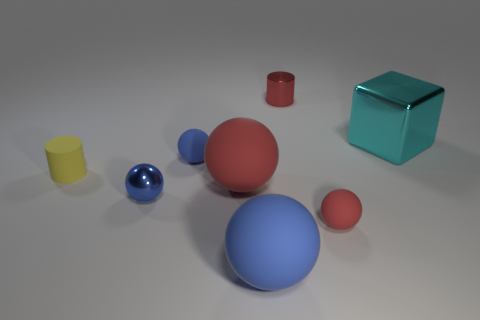Add 1 yellow objects. How many objects exist? 9 Subtract all red spheres. How many spheres are left? 3 Subtract all tiny red matte balls. How many balls are left? 4 Subtract 0 green cylinders. How many objects are left? 8 Subtract all cylinders. How many objects are left? 6 Subtract 1 blocks. How many blocks are left? 0 Subtract all purple balls. Subtract all red blocks. How many balls are left? 5 Subtract all brown cylinders. How many green balls are left? 0 Subtract all tiny blue metal balls. Subtract all blue rubber spheres. How many objects are left? 5 Add 6 big red balls. How many big red balls are left? 7 